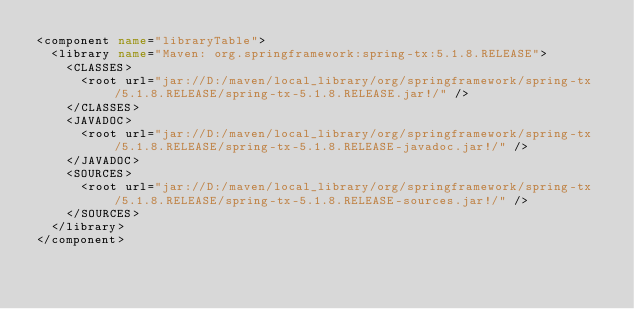<code> <loc_0><loc_0><loc_500><loc_500><_XML_><component name="libraryTable">
  <library name="Maven: org.springframework:spring-tx:5.1.8.RELEASE">
    <CLASSES>
      <root url="jar://D:/maven/local_library/org/springframework/spring-tx/5.1.8.RELEASE/spring-tx-5.1.8.RELEASE.jar!/" />
    </CLASSES>
    <JAVADOC>
      <root url="jar://D:/maven/local_library/org/springframework/spring-tx/5.1.8.RELEASE/spring-tx-5.1.8.RELEASE-javadoc.jar!/" />
    </JAVADOC>
    <SOURCES>
      <root url="jar://D:/maven/local_library/org/springframework/spring-tx/5.1.8.RELEASE/spring-tx-5.1.8.RELEASE-sources.jar!/" />
    </SOURCES>
  </library>
</component></code> 